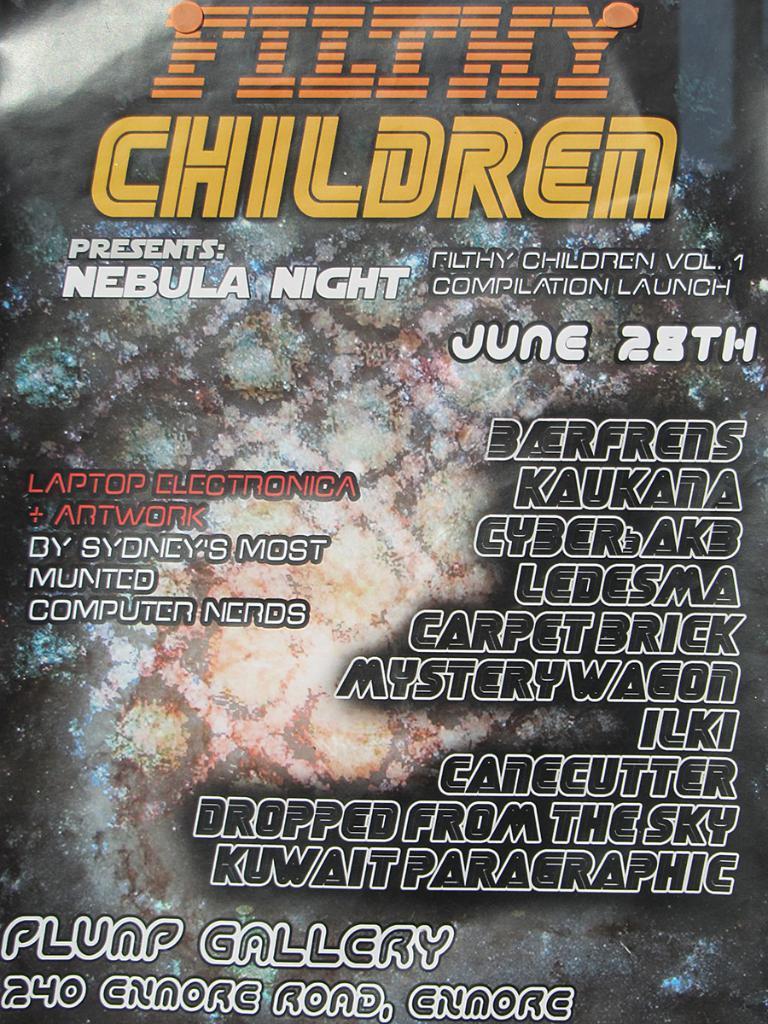In one or two sentences, can you explain what this image depicts? In this picture we can see it might be a design on the floor and there are texts written on the image. 